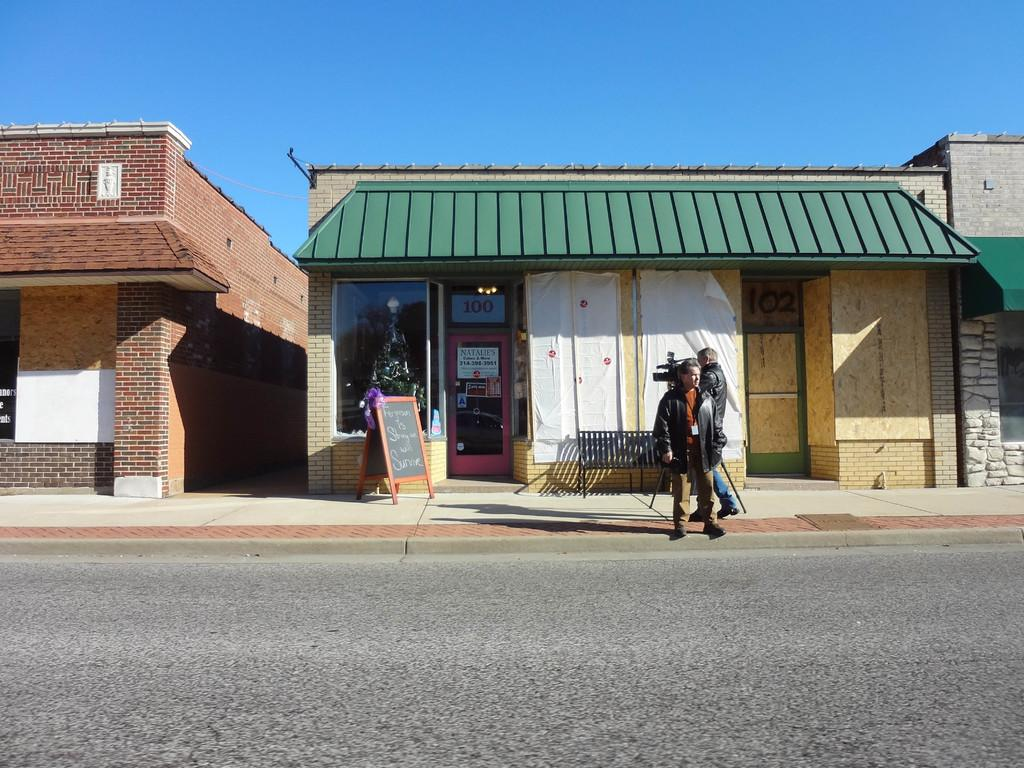What is the main feature of the image? There is a road in the image. Can you describe the people in the image? Two people are standing in the image, and they are wearing jackets. What other objects can be seen in the image? There is a bench and a board in the image. What is visible in the background of the image? There are buildings in the background of the image. What type of cloud can be seen in the image? There is no cloud visible in the image. Can you hear the people in the image crying? There is no indication of crying in the image. 